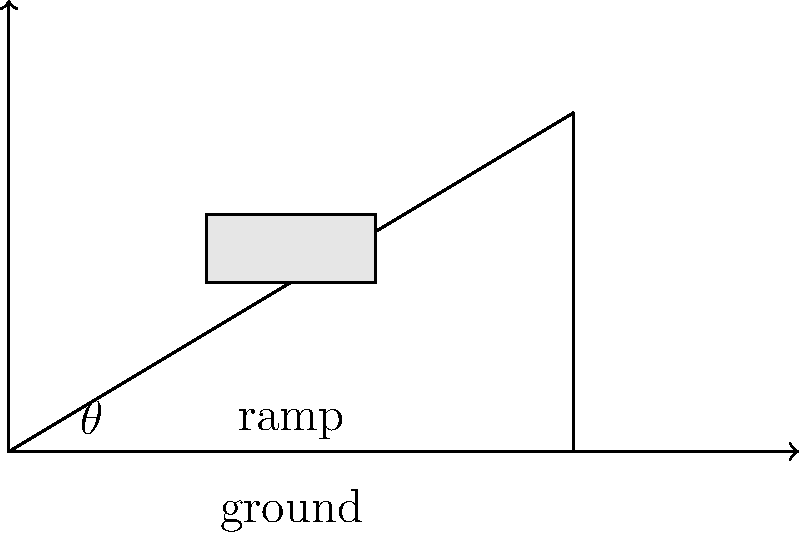You're working on a car that needs to be placed on a ramp for underbody repairs. The ramp is 5 meters long and rises to a height of 3 meters. What's the angle of inclination ($\theta$) of the ramp in degrees? Round your answer to the nearest whole number. To find the angle of inclination, we need to use basic trigonometry:

1) We have a right triangle formed by the ramp, the ground, and the vertical rise.

2) The opposite side (rise) is 3 meters, and the adjacent side (run) is 5 meters.

3) We can use the tangent function to find the angle:

   $\tan(\theta) = \frac{\text{opposite}}{\text{adjacent}} = \frac{3}{5} = 0.6$

4) To get the angle, we need to use the inverse tangent (arctan or $\tan^{-1}$):

   $\theta = \tan^{-1}(0.6)$

5) Using a calculator or trigonometric tables:

   $\theta \approx 30.96375653°$

6) Rounding to the nearest whole number:

   $\theta \approx 31°$
Answer: 31° 